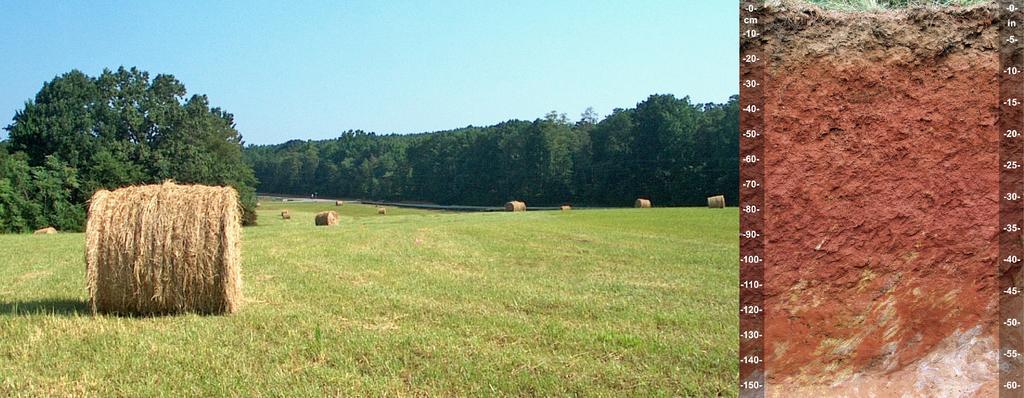Can you describe this image briefly? In this image I can see the grass and trees in green color and I can also see few dried grass rolls and I can see the depth part of the ground. Background the sky is in blue and white color. 